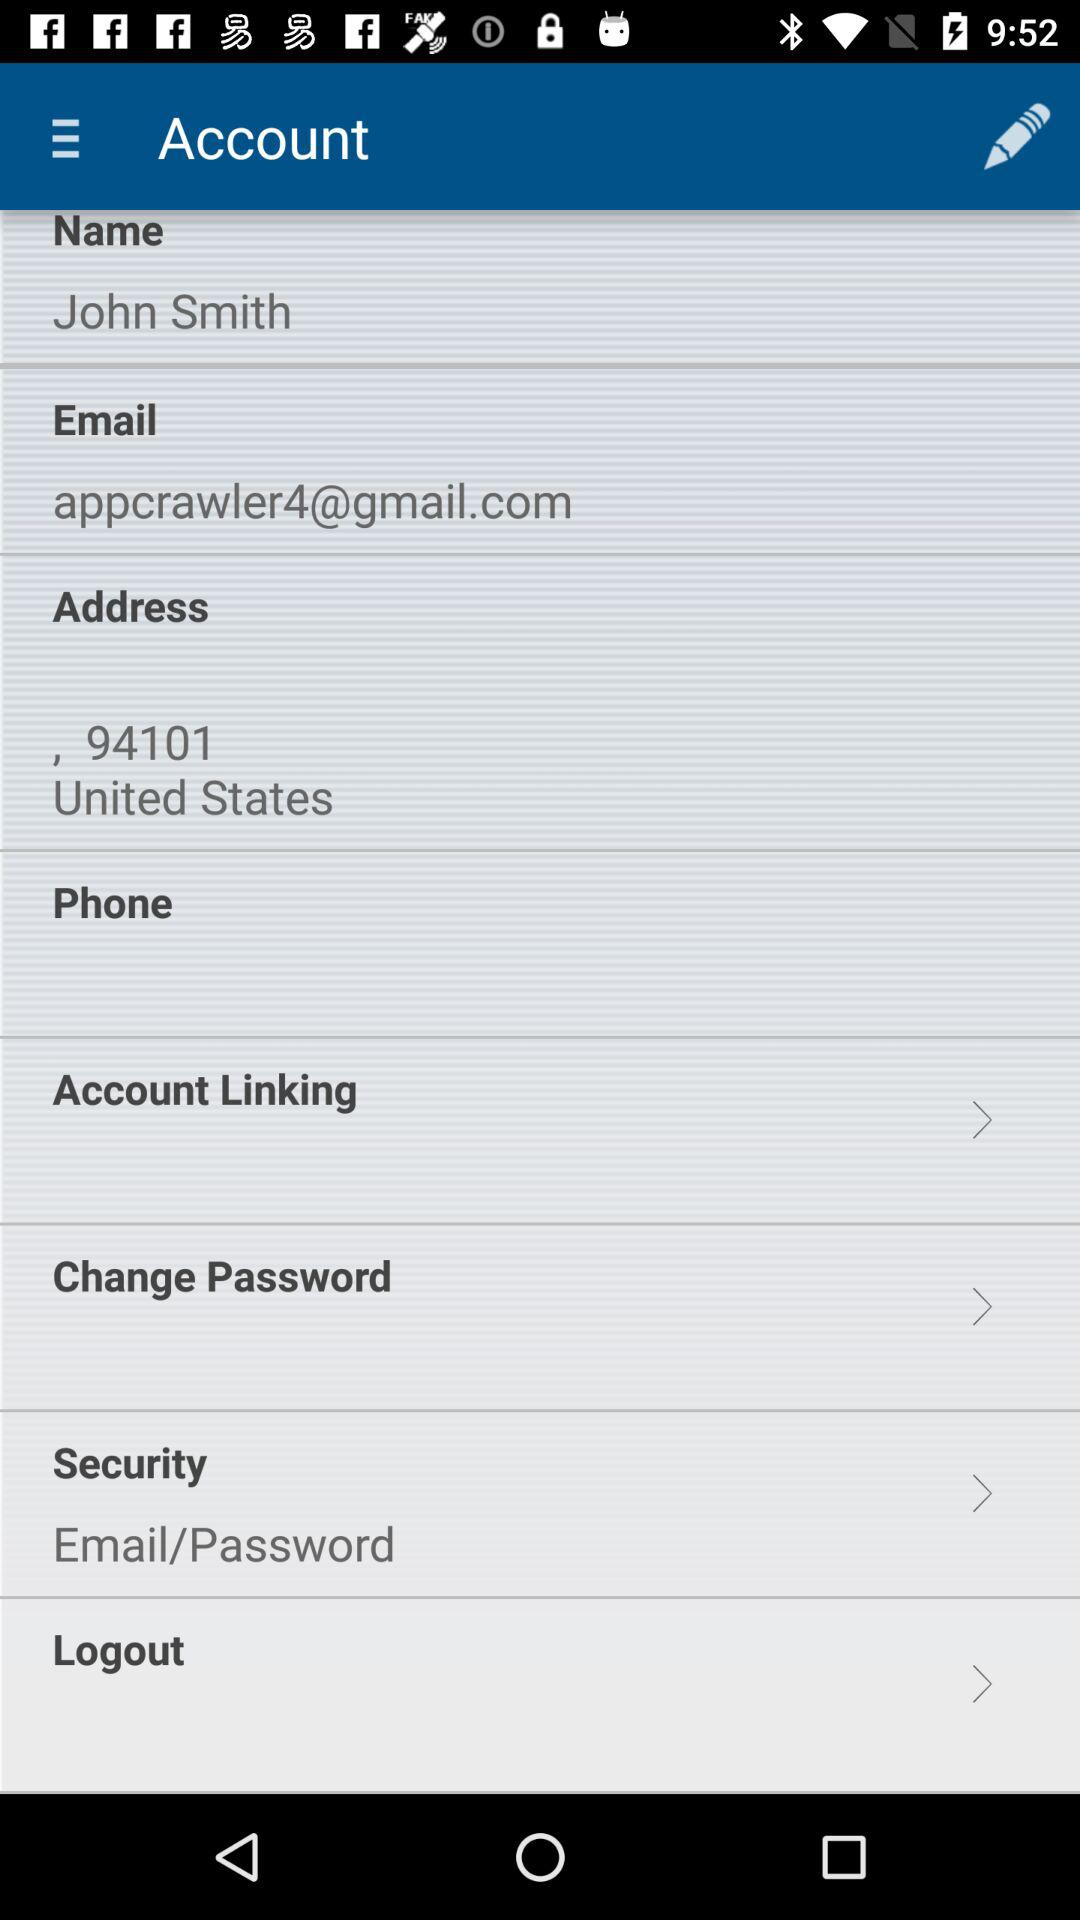What is the address? The address is 94101 in the United States. 